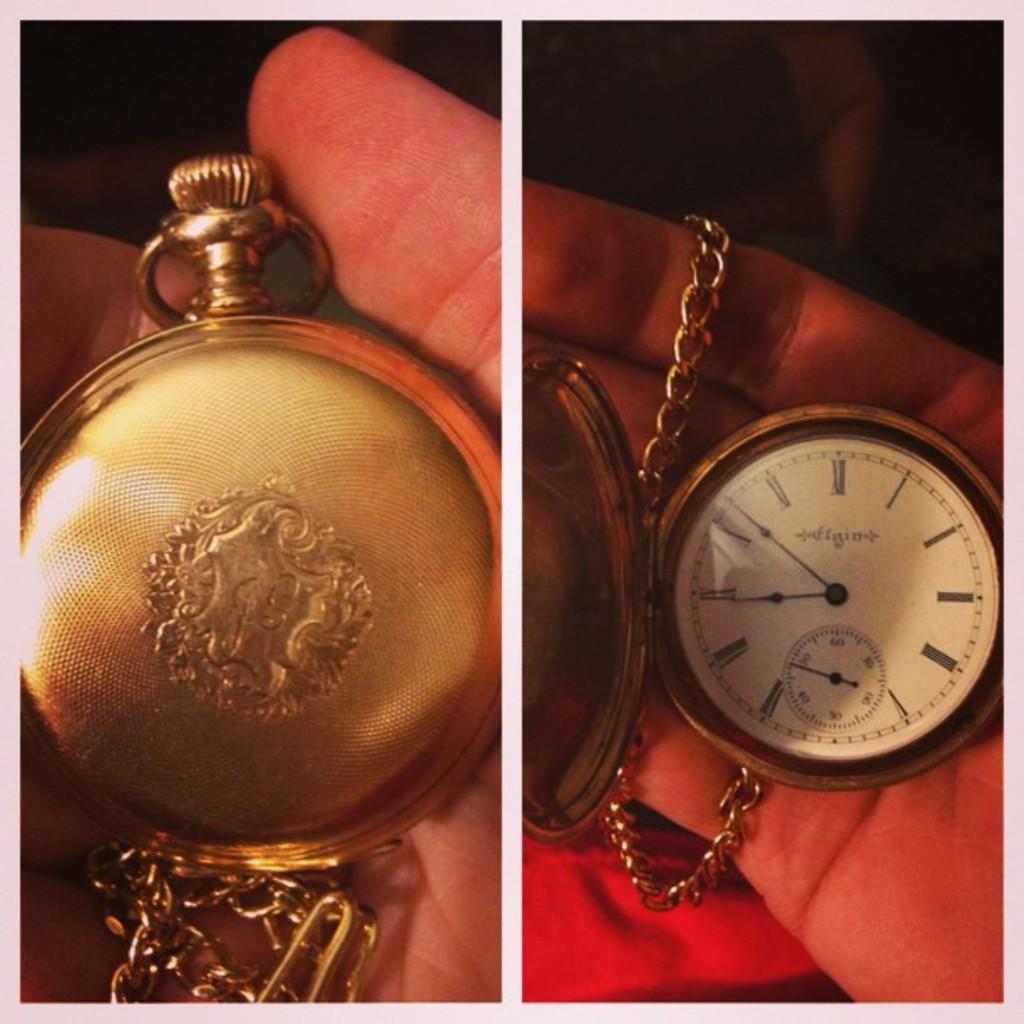What time is it?
Give a very brief answer. 8:52. 